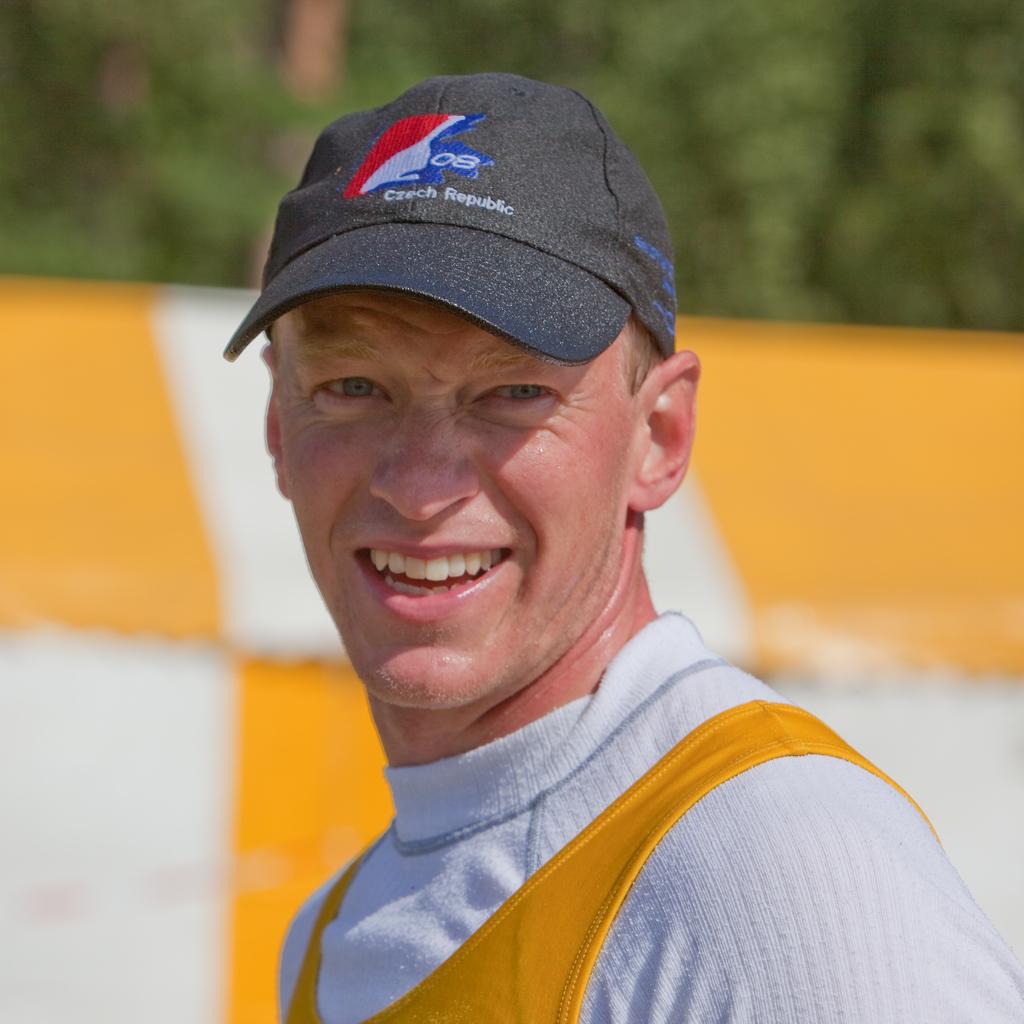What's on his hat?
Keep it short and to the point. Czech republic. Was he born in the czech republic?
Ensure brevity in your answer.  Unanswerable. 